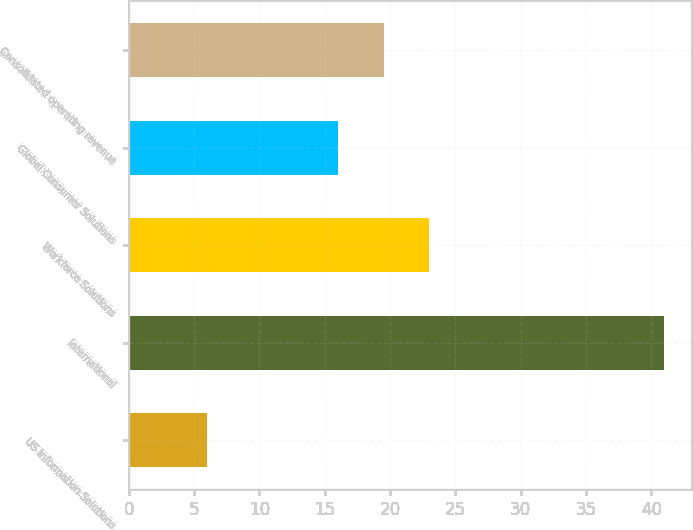Convert chart to OTSL. <chart><loc_0><loc_0><loc_500><loc_500><bar_chart><fcel>US Information Solutions<fcel>International<fcel>Workforce Solutions<fcel>Global Consumer Solutions<fcel>Consolidated operating revenue<nl><fcel>6<fcel>41<fcel>23<fcel>16<fcel>19.5<nl></chart> 